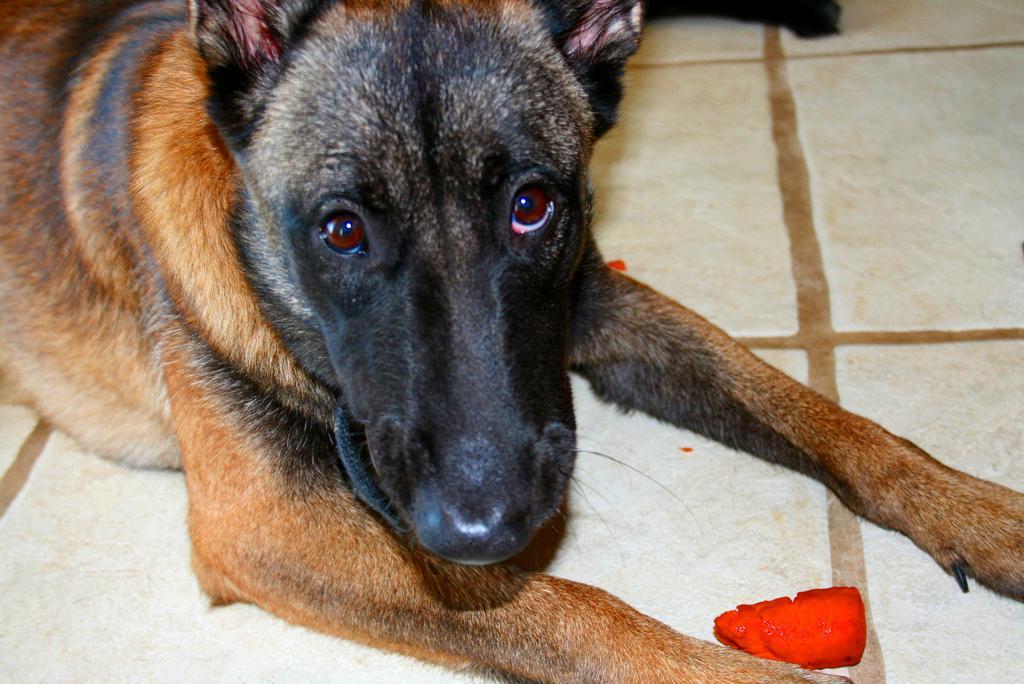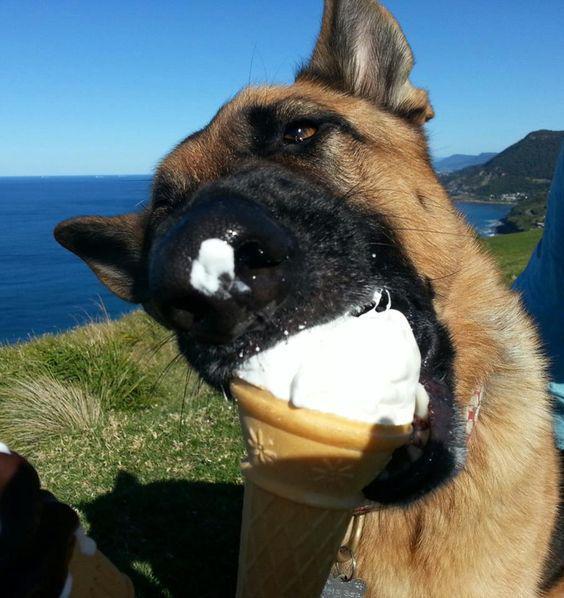The first image is the image on the left, the second image is the image on the right. Assess this claim about the two images: "The left image contains one dog with its tongue hanging out.". Correct or not? Answer yes or no. No. The first image is the image on the left, the second image is the image on the right. Considering the images on both sides, is "The dog in the image on the right is near an area of green grass." valid? Answer yes or no. Yes. 